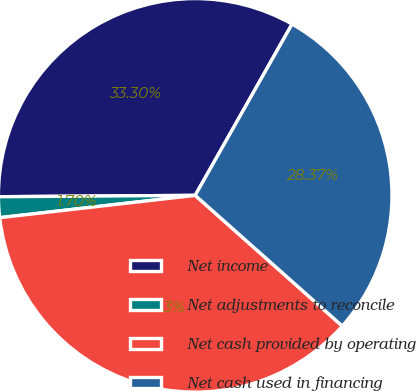<chart> <loc_0><loc_0><loc_500><loc_500><pie_chart><fcel>Net income<fcel>Net adjustments to reconcile<fcel>Net cash provided by operating<fcel>Net cash used in financing<nl><fcel>33.3%<fcel>1.7%<fcel>36.63%<fcel>28.37%<nl></chart> 